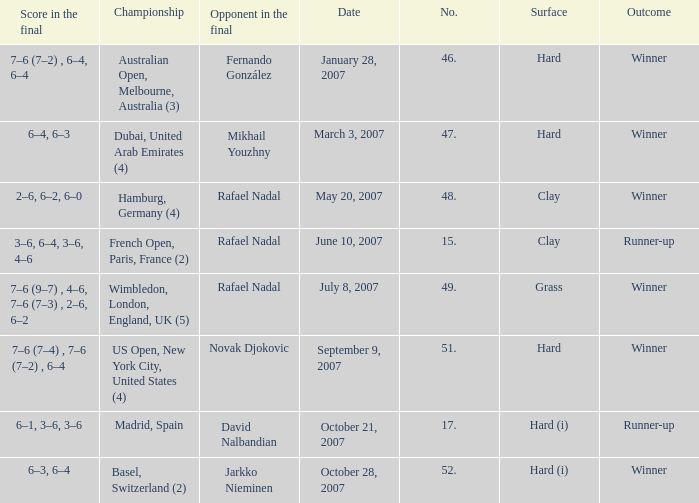Where the outcome is Winner and surface is Hard (i), what is the No.? 52.0. 